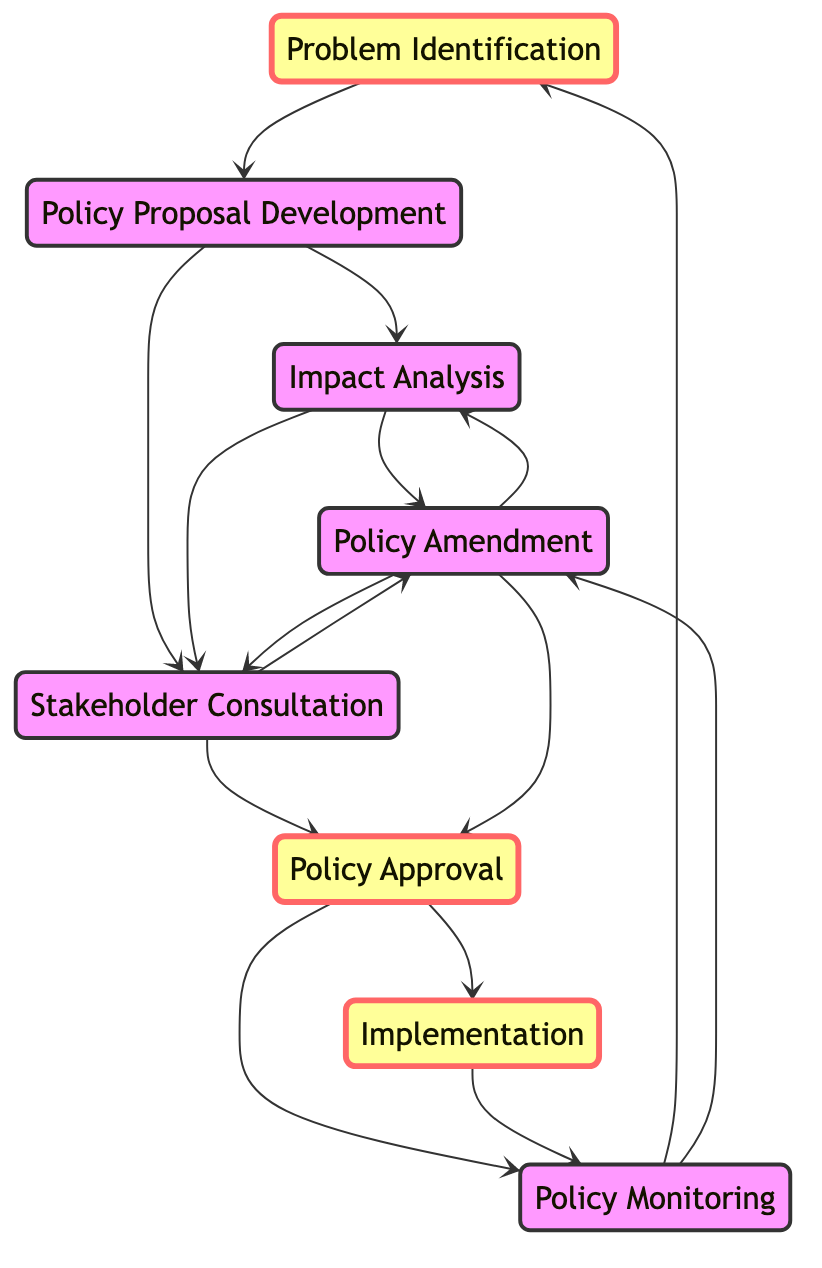What is the first state in the legislative decision-making process? The first state in the diagram is "ProblemIdentification", indicated as the starting point from which transitions occur.
Answer: ProblemIdentification How many states are represented in the diagram? Counting all the unique states listed, there are eight states: ProblemIdentification, PolicyProposalDevelopment, ImpactAnalysis, StakeholderConsultation, PolicyAmendment, PolicyApproval, Implementation, and PolicyMonitoring.
Answer: Eight What is the final state after the "PolicyApproval" stage? After the "PolicyApproval" stage, the flow in the diagram indicates two potential paths: "Implementation" and "PolicyMonitoring", but Implementation is identified as the execution phase following approval.
Answer: Implementation Which state comes after "ImpactAnalysis"? From the diagram, the state "ImpactAnalysis" can transition to either "PolicyAmendment" or "StakeholderConsultation". Both are valid, but only focusing on one for the question, we can list either depending on context.
Answer: PolicyAmendment or StakeholderConsultation How many transitions lead to "PolicyApproval"? The transitions leading to "PolicyApproval" originate from "StakeholderConsultation" and "PolicyAmendment", totaling three paths when including "StakeholderConsultation" transitioning directly, which means it can receive input from multiple points.
Answer: Two What can happen after the "PolicyMonitoring" state? Following the "PolicyMonitoring" state, there are two potential transitions depicted in the diagram: it can either revert to "ProblemIdentification" or lead to "PolicyAmendment". This indicates ongoing loops based on evaluation results.
Answer: ProblemIdentification or PolicyAmendment Which state is labeled as an important state? The states that have been categorized as important include "ProblemIdentification", "PolicyApproval", and "Implementation", highlighted through distinct formatting in the diagram design.
Answer: ProblemIdentification, PolicyApproval, Implementation Which state is directly connected to both "PolicyAmendment" and "ImpactAnalysis"? "StakeholderConsultation" directly connects to both "PolicyAmendment" and "ImpactAnalysis" as shown in the transition lines between these states.
Answer: StakeholderConsultation 